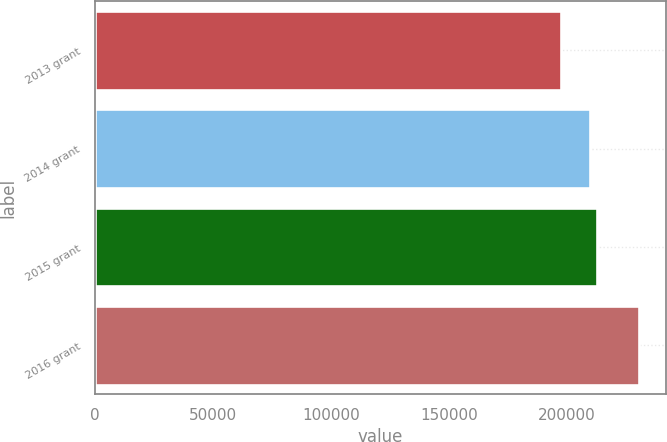Convert chart to OTSL. <chart><loc_0><loc_0><loc_500><loc_500><bar_chart><fcel>2013 grant<fcel>2014 grant<fcel>2015 grant<fcel>2016 grant<nl><fcel>197500<fcel>209750<fcel>213050<fcel>230500<nl></chart> 